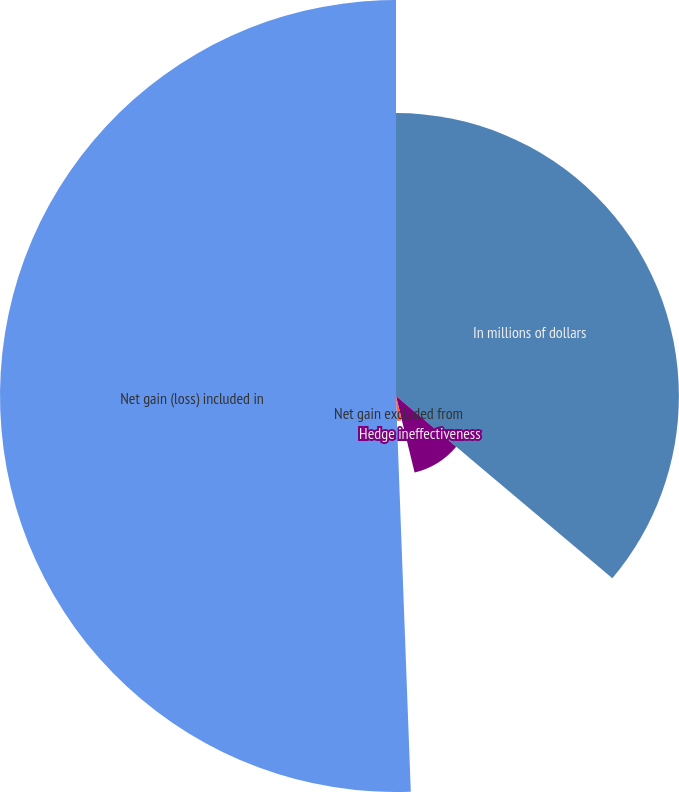Convert chart to OTSL. <chart><loc_0><loc_0><loc_500><loc_500><pie_chart><fcel>In millions of dollars<fcel>Hedge ineffectiveness<fcel>Net gain excluded from<fcel>Net gain (loss) included in<nl><fcel>36.14%<fcel>10.06%<fcel>3.2%<fcel>50.59%<nl></chart> 